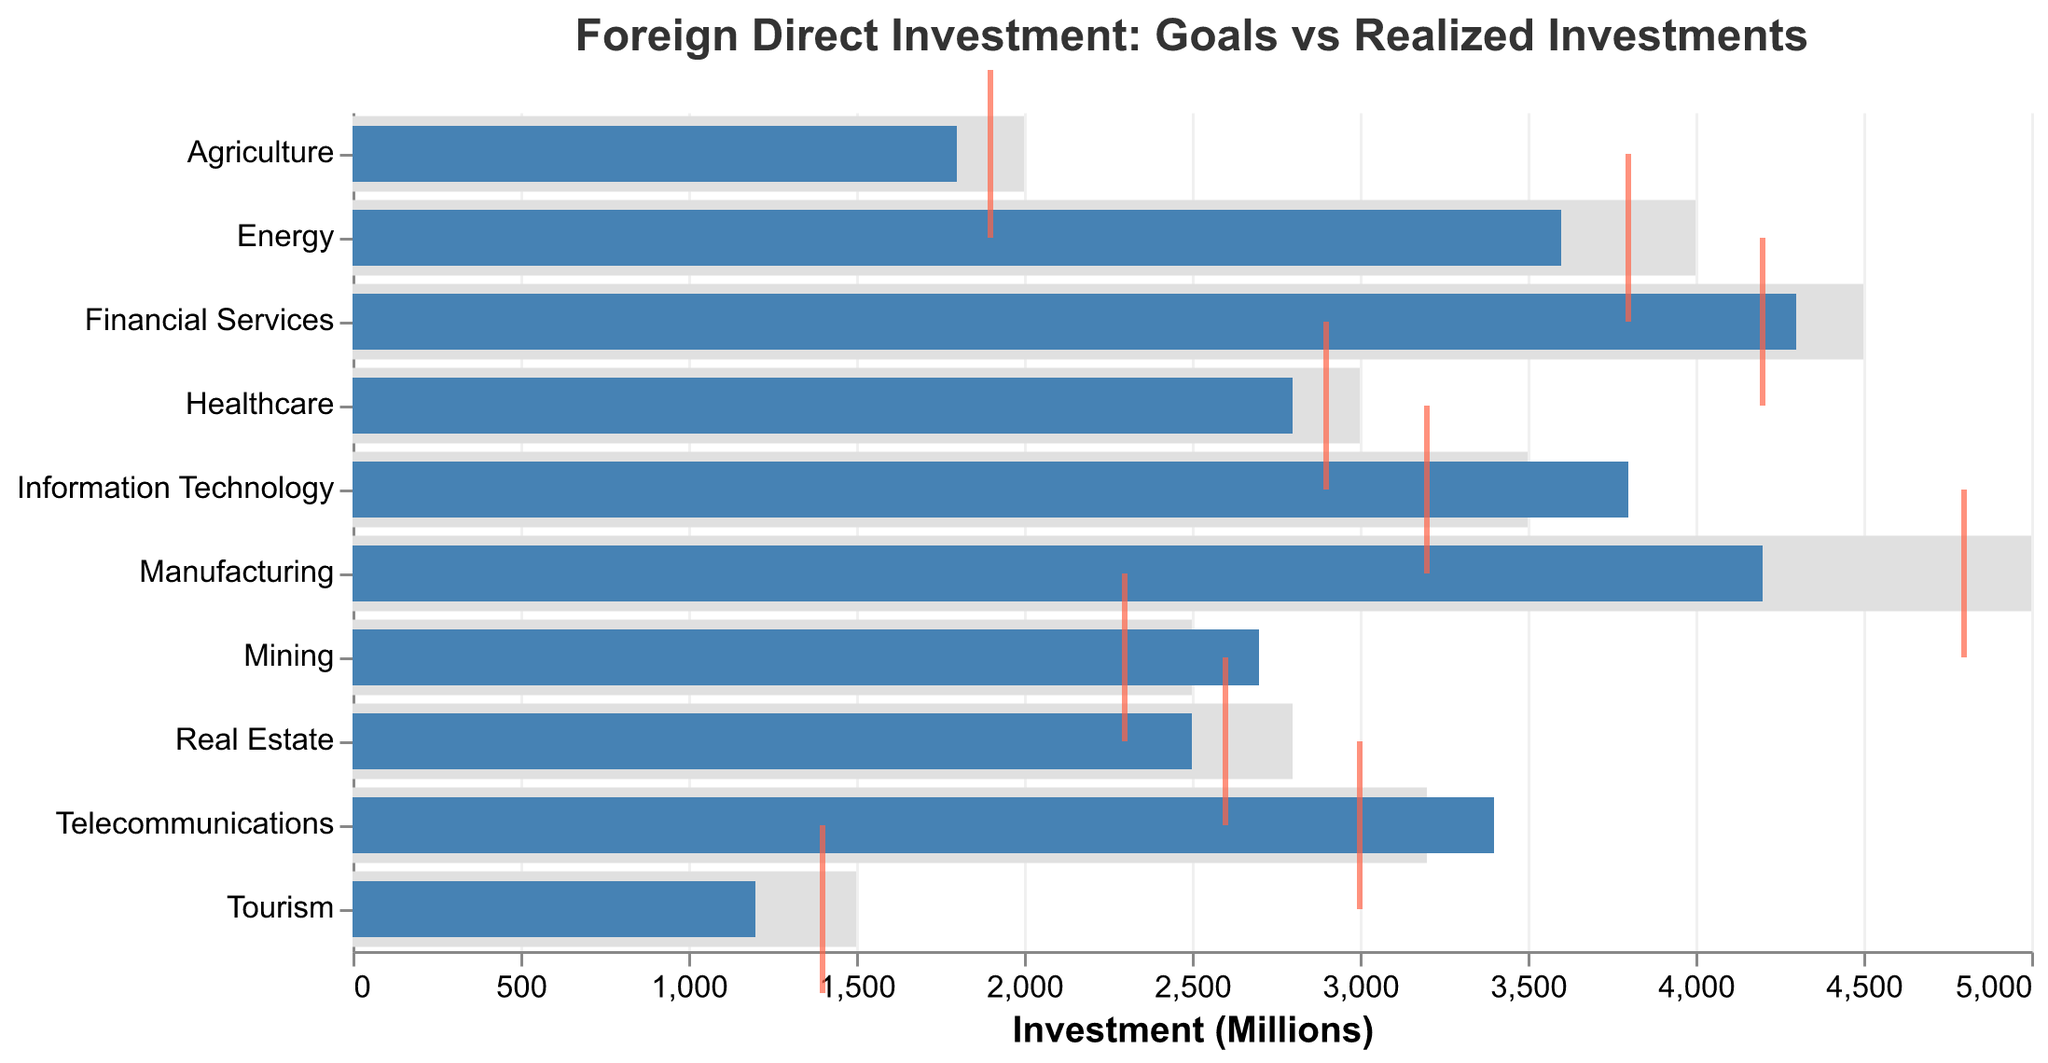What's the title of the chart? The title of the chart is usually displayed at the top and it sets the context for the information being presented. In this case, it identifies that the chart is about comparing foreign direct investment goals versus realized investments.
Answer: Foreign Direct Investment: Goals vs Realized Investments Which sector has the highest realized investment? Look at the bar representing realized investments for each sector and identify which one extends furthest to the right.
Answer: Information Technology What is the realized investment amount for the Energy sector? Find the Energy sector on the chart and look for the length of the blue bar, which indicates the realized investment.
Answer: 3600 million Is the benchmark for Agriculture higher or lower than its realized investment? Compare the position of the tick mark (representing the benchmark) to the end of the blue bar (representing the realized investment) for Agriculture.
Answer: Higher Which sectors have realized investments that exceed their goals? Compare each sector's blue bar (realized) to its light grey bar (goal) to determine which ones have blue bars longer than the grey bars.
Answer: Information Technology, Mining, Telecommunications How much more do the Information Technology sector's realized investments exceed its goal by? Subtract the goal of Information Technology from its realized investment: 3800 - 3500.
Answer: 300 million Which sector has the smallest difference between its benchmark and realized investment? Calculate the absolute differences between the benchmark and realized values for each sector, and find the smallest one.
Answer: Telecommunications What can be inferred if a sector's realized investment is below both its goal and benchmark? Draw conclusions based on the relationship between the blue bar (realized) and both the grey bar (goal) and the red tick (benchmark).
Answer: The sector underperformed in attracting investments Of the sectors that didn't meet their goals, which one came closest to achieving it? Among the sectors where the realized investment (blue bar) is smaller than the goal (grey bar), find the smallest difference.
Answer: Energy How many sectors have a benchmark lower than their goal but still managed to exceed the benchmark in realized investments? Identify sectors where the red tick (benchmark) is to the left of the grey bar (goal), but the blue bar (realized) extends beyond the tick.
Answer: Four sectors (Agriculture, Energy, Financial Services, Real Estate) 